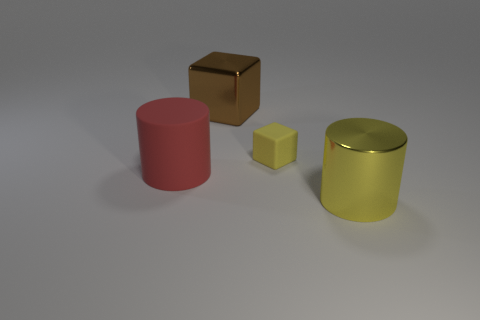Describe the lighting and shadows in the image. The image appears to be illuminated by a light source coming from above and slightly to the right, as indicated by the shadows cast on the ground. Each object casts a distinct shadow that matches its shape, confirming the light source's position. The softness of the shadows suggests diffused lighting, possibly indicating an indoor environment with ambient light. 